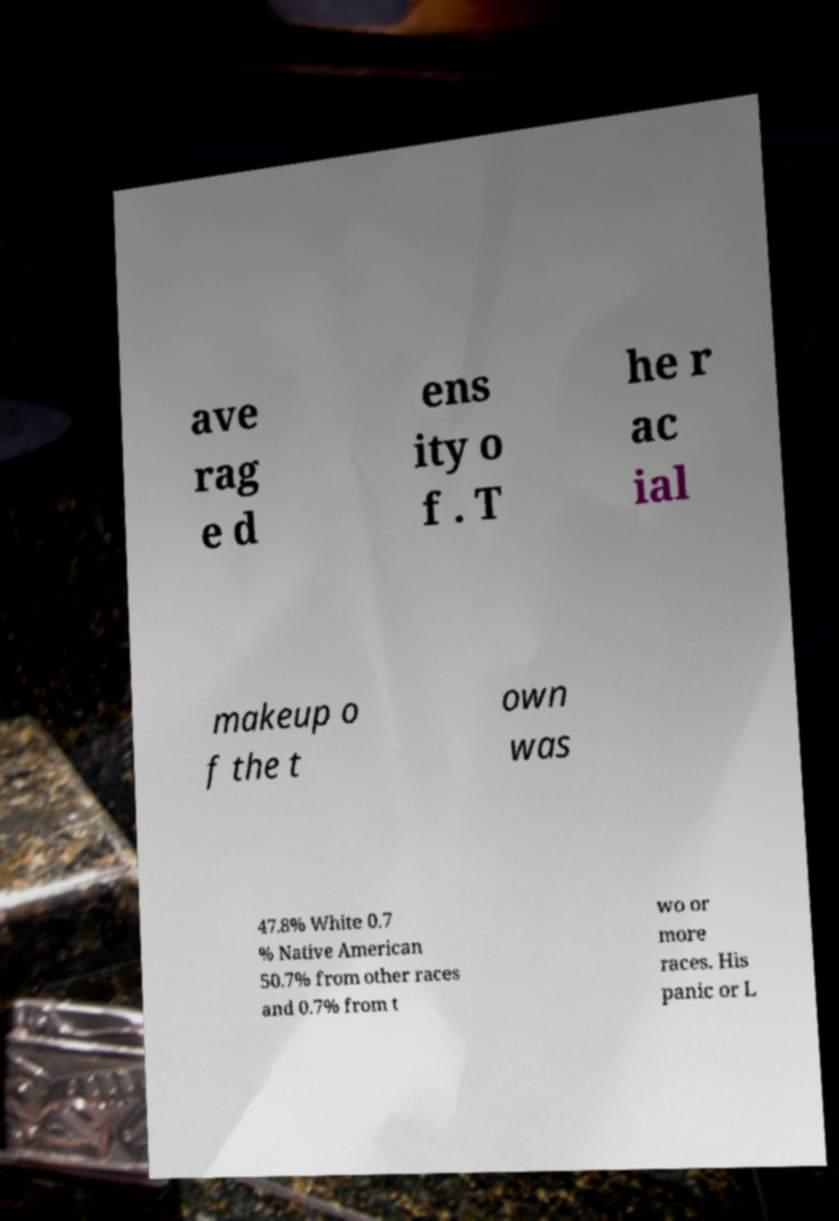Please identify and transcribe the text found in this image. ave rag e d ens ity o f . T he r ac ial makeup o f the t own was 47.8% White 0.7 % Native American 50.7% from other races and 0.7% from t wo or more races. His panic or L 